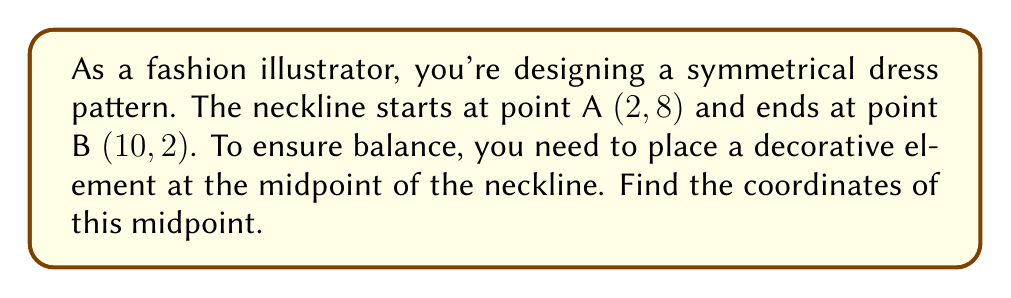Provide a solution to this math problem. To find the midpoint between two points, we use the midpoint formula:

$$ \text{Midpoint} = \left(\frac{x_1 + x_2}{2}, \frac{y_1 + y_2}{2}\right) $$

Where $(x_1, y_1)$ are the coordinates of the first point and $(x_2, y_2)$ are the coordinates of the second point.

Given:
- Point A: (2, 8)
- Point B: (10, 2)

Let's substitute these values into the midpoint formula:

$$ \text{Midpoint} = \left(\frac{2 + 10}{2}, \frac{8 + 2}{2}\right) $$

Now, let's calculate each coordinate:

For the x-coordinate:
$$ \frac{2 + 10}{2} = \frac{12}{2} = 6 $$

For the y-coordinate:
$$ \frac{8 + 2}{2} = \frac{10}{2} = 5 $$

Therefore, the midpoint coordinates are (6, 5).

[asy]
unitsize(0.5cm);
draw((-1,-1)--(12,10), gray);
dot((2,8),red);
dot((10,2),red);
dot((6,5),blue);
label("A (2,8)", (2,8), NE);
label("B (10,2)", (10,2), SE);
label("Midpoint (6,5)", (6,5), E);
draw((2,8)--(10,2), red);
[/asy]
Answer: The coordinates of the midpoint are (6, 5). 